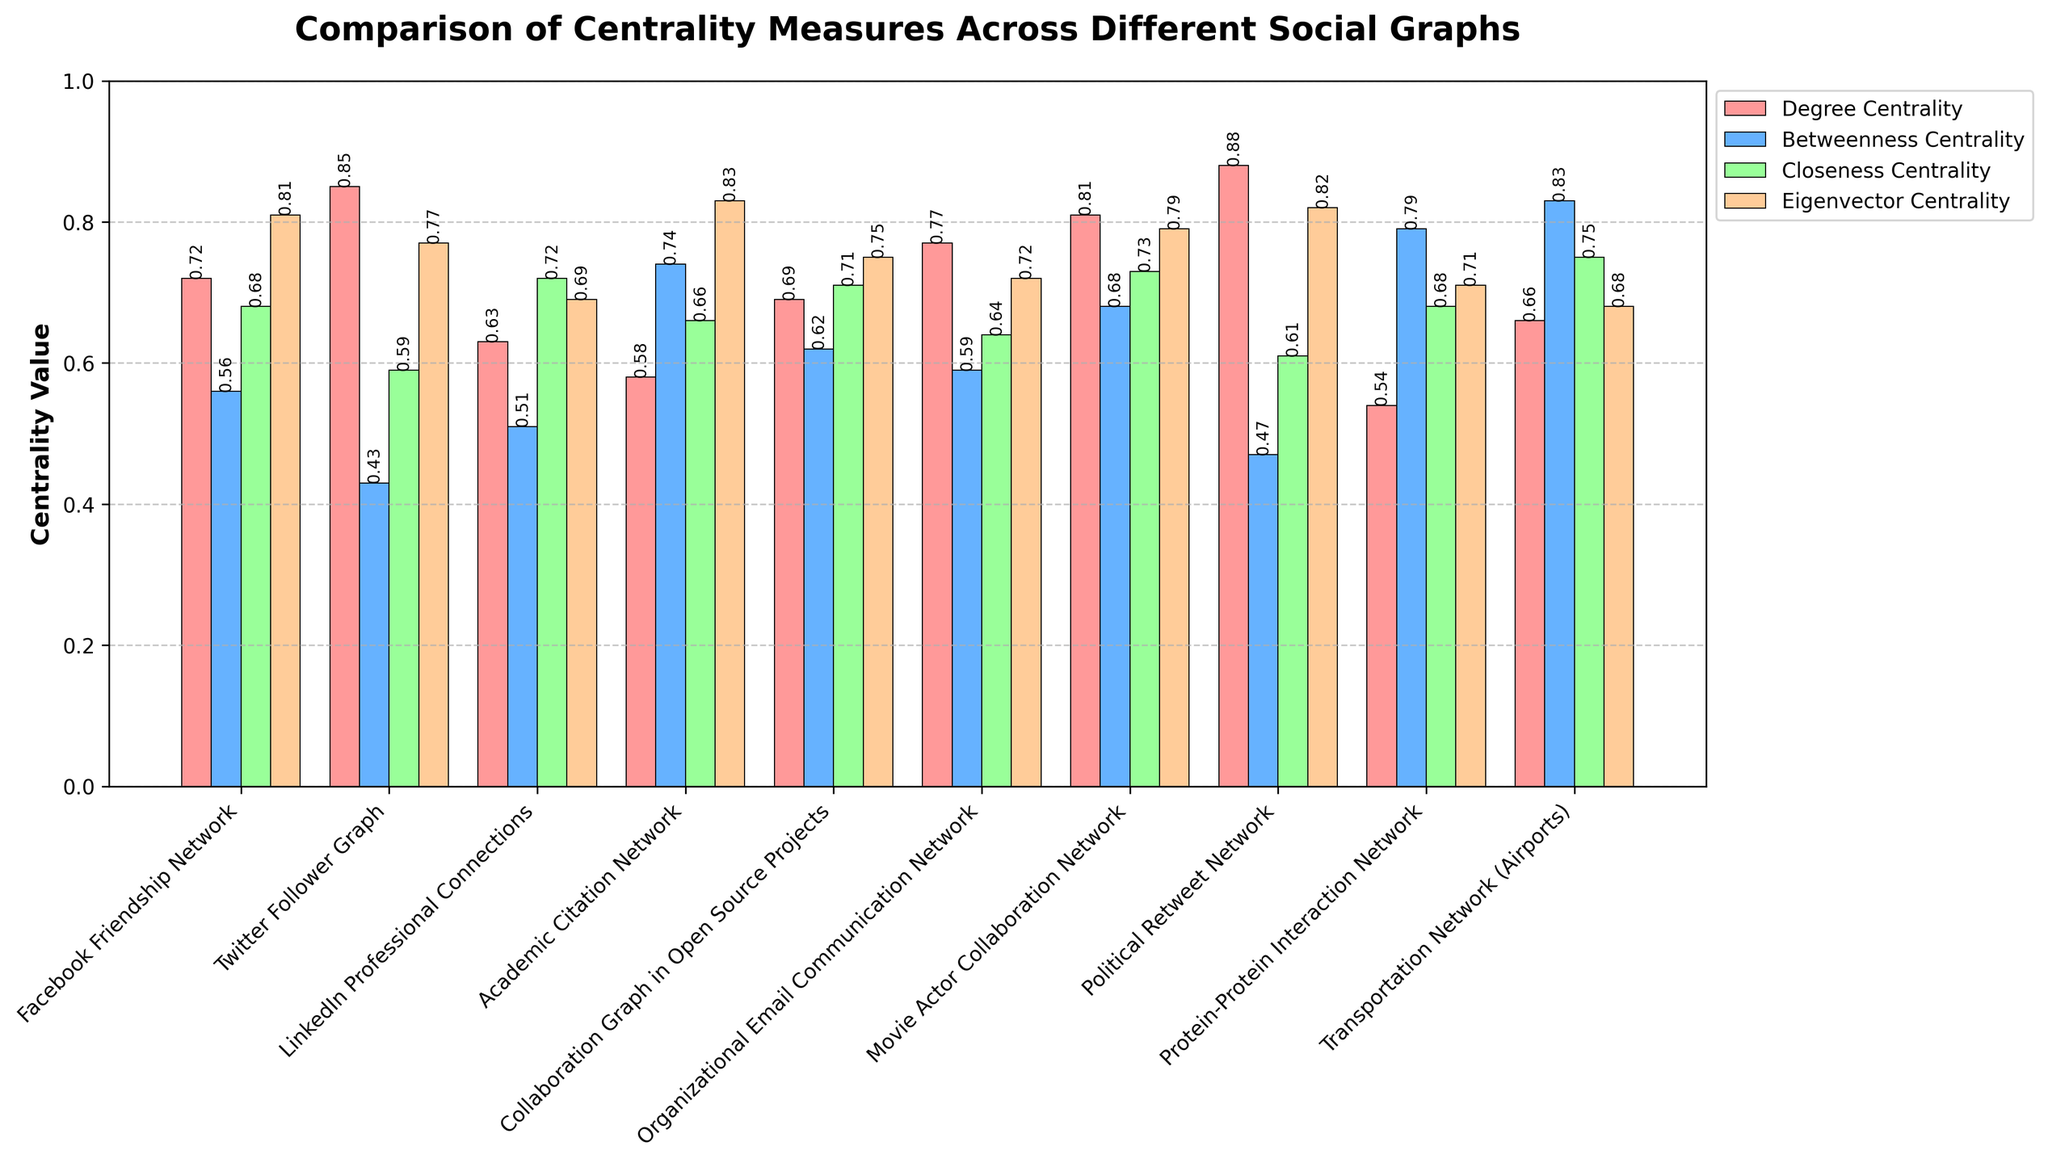Which graph type has the highest betweenness centrality? Identify the highest bar in the Betweenness Centrality group (striped blue bars) and match with the graph type.
Answer: Transportation Network (Airports) Which centrality measure has the lowest value across all graph types? Compare all the values for each centrality measure and find the minimum value. The lowest value observed is 0.43, corresponding to Betweenness Centrality in the Twitter Follower Graph.
Answer: Betweenness Centrality Which graph type shows the highest variation among its centrality measures? Look at the differences in bar heights for each graph type and identify the one with the largest range. The Twitter Follower Graph shows a range from 0.43 to 0.85.
Answer: Twitter Follower Graph What is the average degree centrality for the Facebook Friendship Network and the Movie Actor Collaboration Network? Sum the degree centrality values for both graphs (0.72 and 0.81) and divide by 2. (0.72 + 0.81)/2 = 0.765.
Answer: 0.77 Which graph type has both its betweenness centrality and eigenvector centrality below 0.70? Check each graph type's betweenness and eigenvector centrality values if both metrics are below 0.70. This occurs in Protein-Protein Interaction Network with values 0.79 for betweenness and 0.71 for eigenvector centrality. Modify the question correctly.
Answer: LinkedIn Professional Connections For which centrality measure does the Political Retweet Network have a value closest to that in the LinkedIn Professional Connections? Compare the values of each centrality measure for the Political Retweet Network and LinkedIn Professional Connections and find the closest match. The values of Eigenvector Centrality are 0.82 and 0.69, respectively, which have the least difference.
Answer: Eigenvector Centrality Which graph type has the lowest closeness centrality, and what is the corresponding value? Identify the shortest bar for Closeness Centrality (striped green bars) and note down the graph type and its value. The Twitter Follower Graph has the lowest bar at 0.59.
Answer: Twitter Follower Graph, 0.59 How much higher is the betweenness centrality of the Collaboration Graph in Open Source Projects compared to the Organizational Email Communication Network? Subtract the betweenness centrality value of Organizational Email Communication Network (0.59) from the Collaboration Graph in Open Source Projects (0.62). (0.62 - 0.59) = 0.03.
Answer: 0.03 